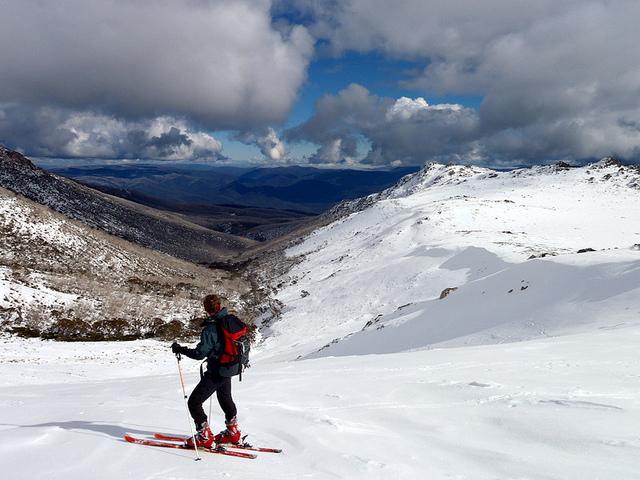What is he doing?
Concise answer only. Skiing. Is the skier at the top or bottom of the mountain?
Give a very brief answer. Top. Are both his skis in contact with the snow?
Write a very short answer. Yes. 